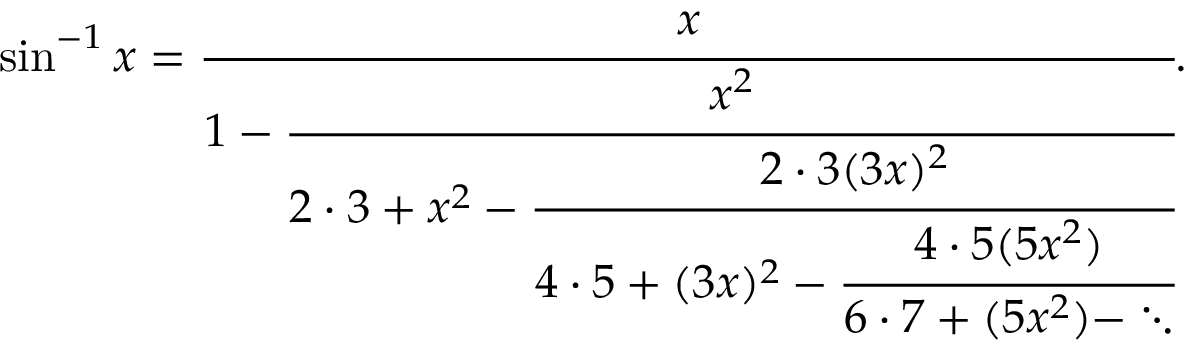<formula> <loc_0><loc_0><loc_500><loc_500>\sin ^ { - 1 } x = { \cfrac { x } { 1 - { \cfrac { x ^ { 2 } } { 2 \cdot 3 + x ^ { 2 } - { \cfrac { 2 \cdot 3 ( 3 x ) ^ { 2 } } { 4 \cdot 5 + ( 3 x ) ^ { 2 } - { \cfrac { 4 \cdot 5 ( 5 x ^ { 2 } ) } { 6 \cdot 7 + ( 5 x ^ { 2 } ) - \ddots } } } } } } } } .</formula> 